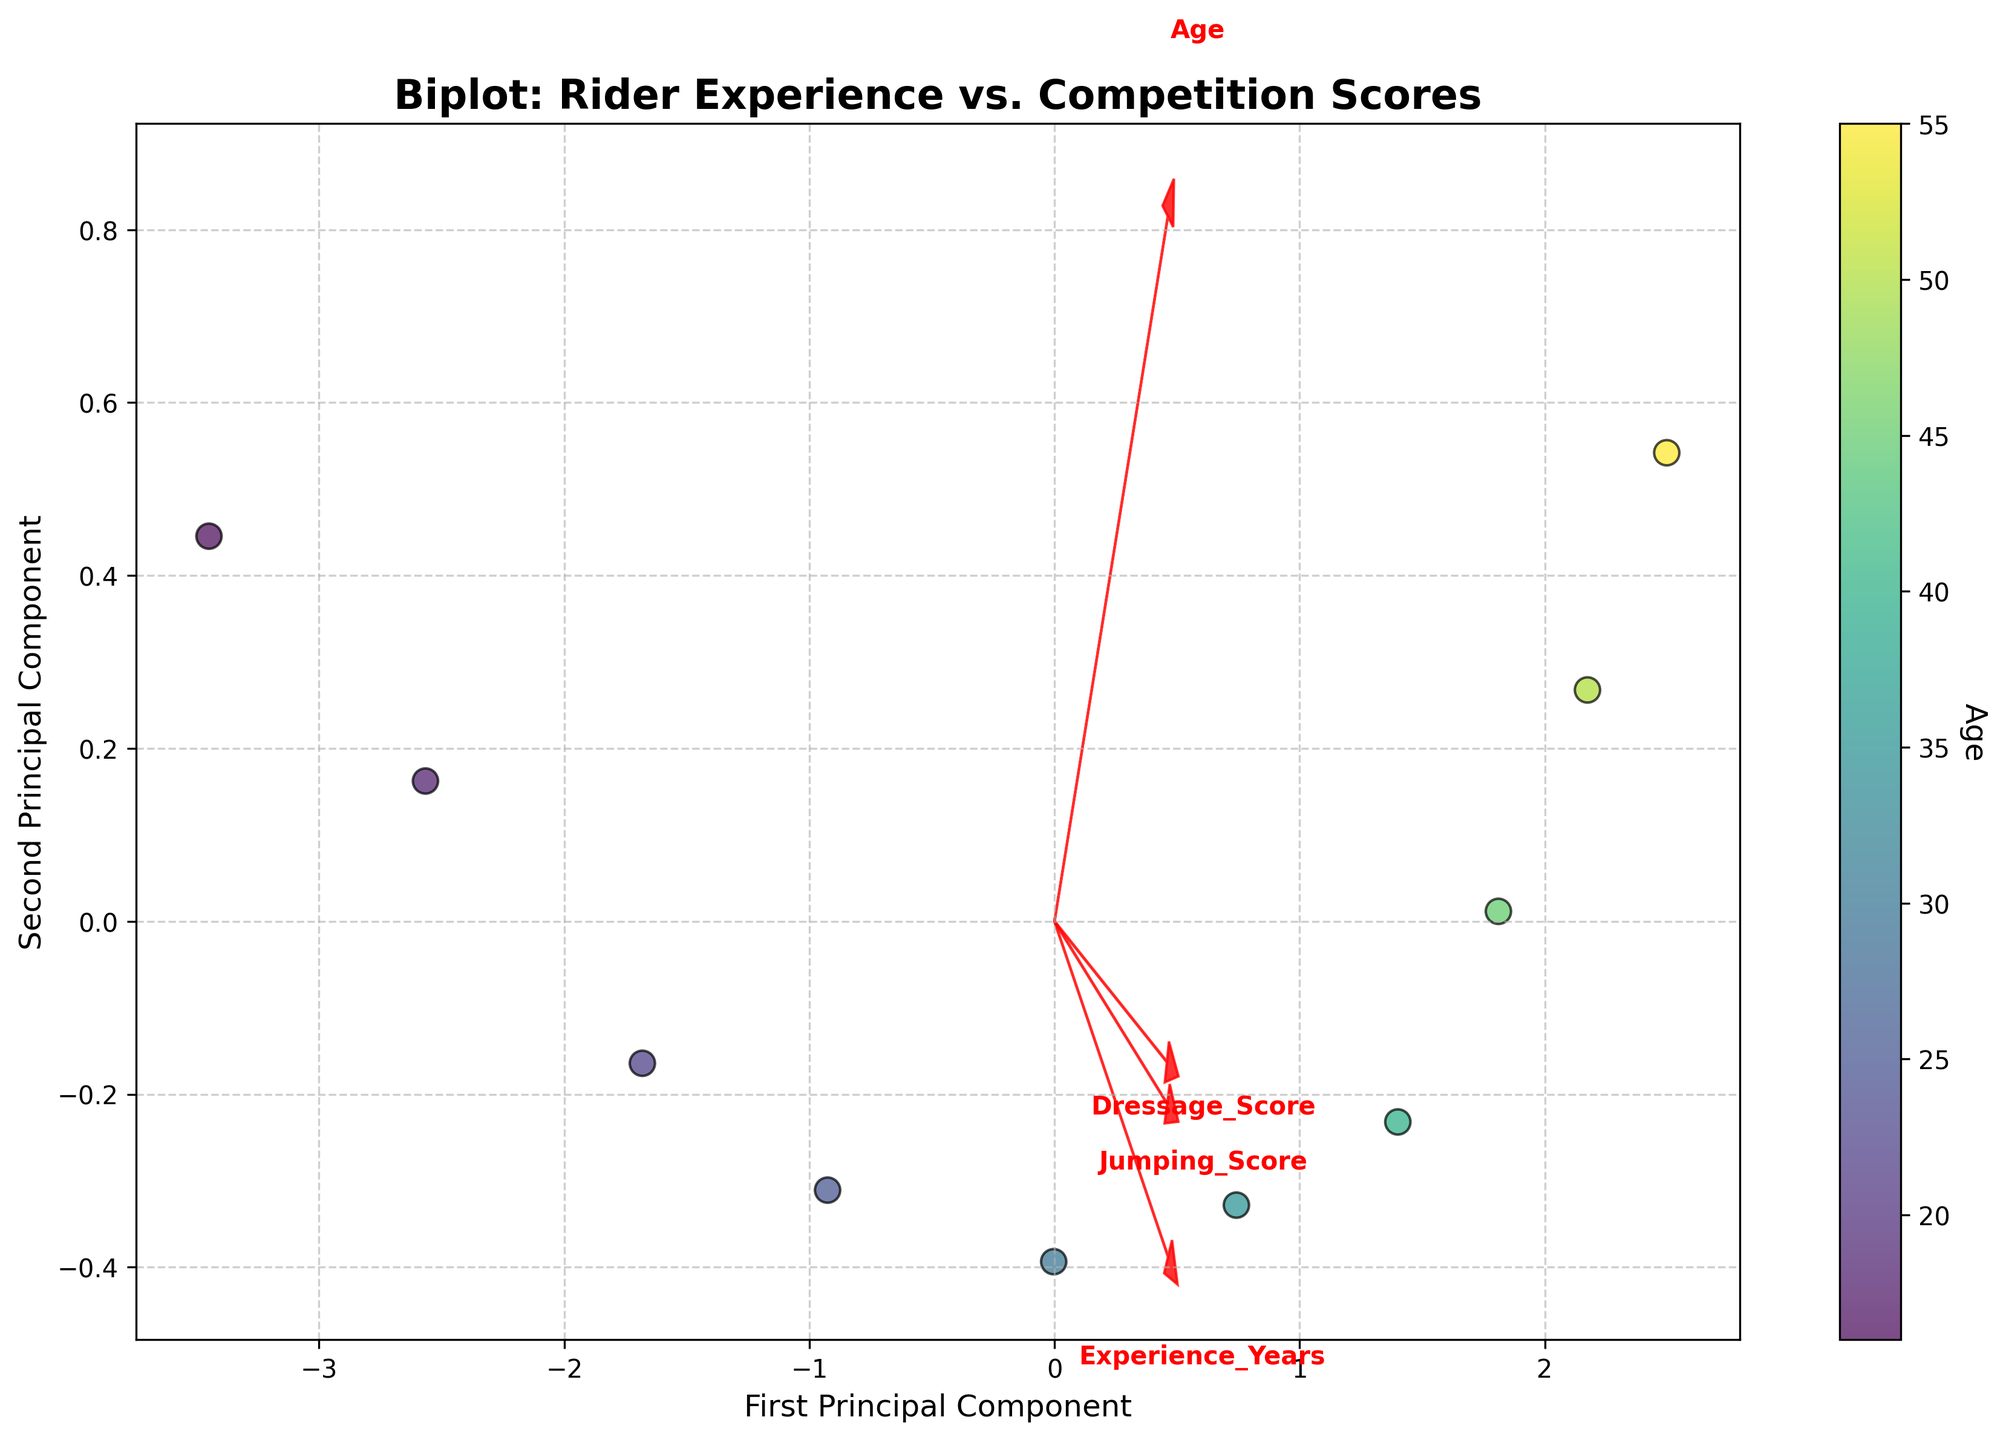What is the title of the plot? The title is located at the top of the plot. It provides an overall description of what the plot is about.
Answer: Biplot: Rider Experience vs. Competition Scores What are the two principal components labeled on the axes? The axis labels are found on the edges of the plot. They represent the principal components derived from the PCA analysis.
Answer: First Principal Component and Second Principal Component How many data points are displayed in the plot? Each data point is represented by a scatter point on the plot. Counting these scatter points will give the number of data points.
Answer: 10 Which color represents the highest age group? The color bar on the right side of the plot shows the gradient of colors used to represent different age groups. The end of the color bar that corresponds to the highest value will show the color for the highest age group.
Answer: A shade near the top of the color bar (darker green) Which feature vector is longest, indicating it contributes the most to the principal components? The feature vectors are the arrows on the plot. The length of the arrow represents the relative contribution of that feature to the principal components.
Answer: The feature representing 'Experience_Years' Which elements on the plot denote the competition scores? The plot includes arrows labeled with each component's name. Identifying which arrows are associated with Dressage, Jumping, and Cross Country indicates the competition scores.
Answer: The arrows labeled Dressage_Score, Jumping_Score, and Cross_Country_Score How does the arrow for the 'Experience_Years' vector compare with the arrows for 'Dressage_Score' in terms of direction? By examining the direction and relative positioning of the arrows, we can determine the relationship and orientation between 'Experience_Years' and 'Dressage_Score'.
Answer: Nearly aligned and extending to similar regions in the plot Which principal component captures more variance in the data? The principal component that captures more variance generally has larger loadings, which can be inferred from the contributions of the feature vectors. The direction with the most spread of data points also indicates this.
Answer: The axis for the First Principal Component Are the feature vectors for 'Jumping_Score' and 'Cross_Country_Score' more closely aligned with each other or with 'Experience_Years'? By observing the angles and directions between these arrows, we can determine which arrows are more aligned relative to each other.
Answer: 'Jumping_Score' and 'Cross_Country_Score' are more closely aligned with each other Which age group seems to have the highest scores across all the events? Points colored at the highest value of the color gradient represent the highest age group. Identify the positions of these points relative to the arrows indicating high scores in Dressage, Jumping, and Cross Country.
Answer: The highest age group (represented by the darker green color) has the highest scores across all events 